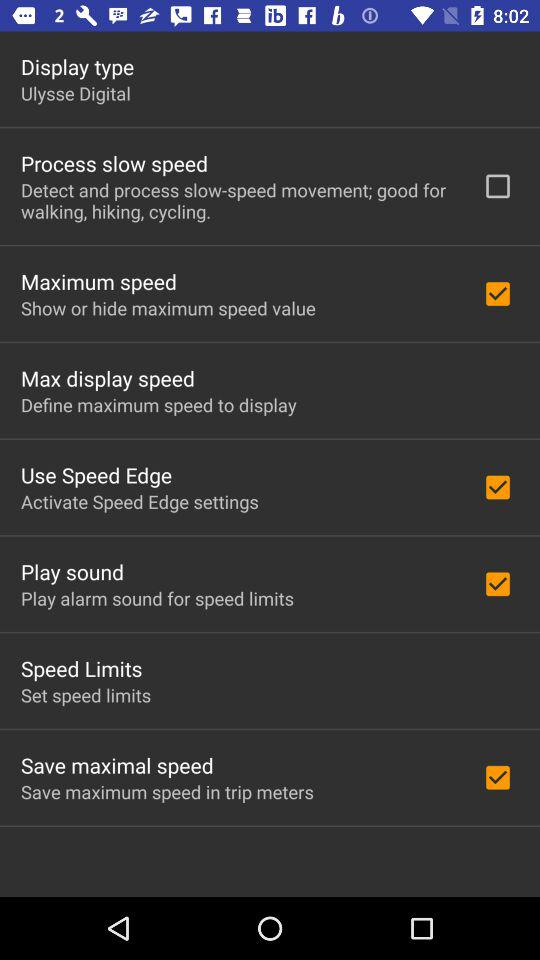What is the status of "Play sound"? The status is "on". 